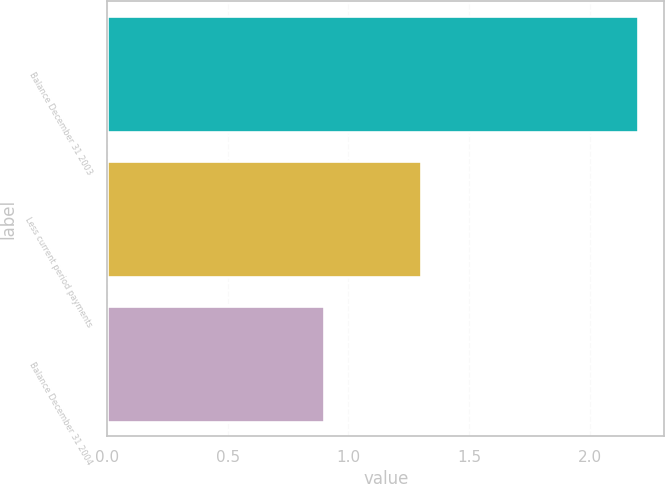Convert chart to OTSL. <chart><loc_0><loc_0><loc_500><loc_500><bar_chart><fcel>Balance December 31 2003<fcel>Less current period payments<fcel>Balance December 31 2004<nl><fcel>2.2<fcel>1.3<fcel>0.9<nl></chart> 